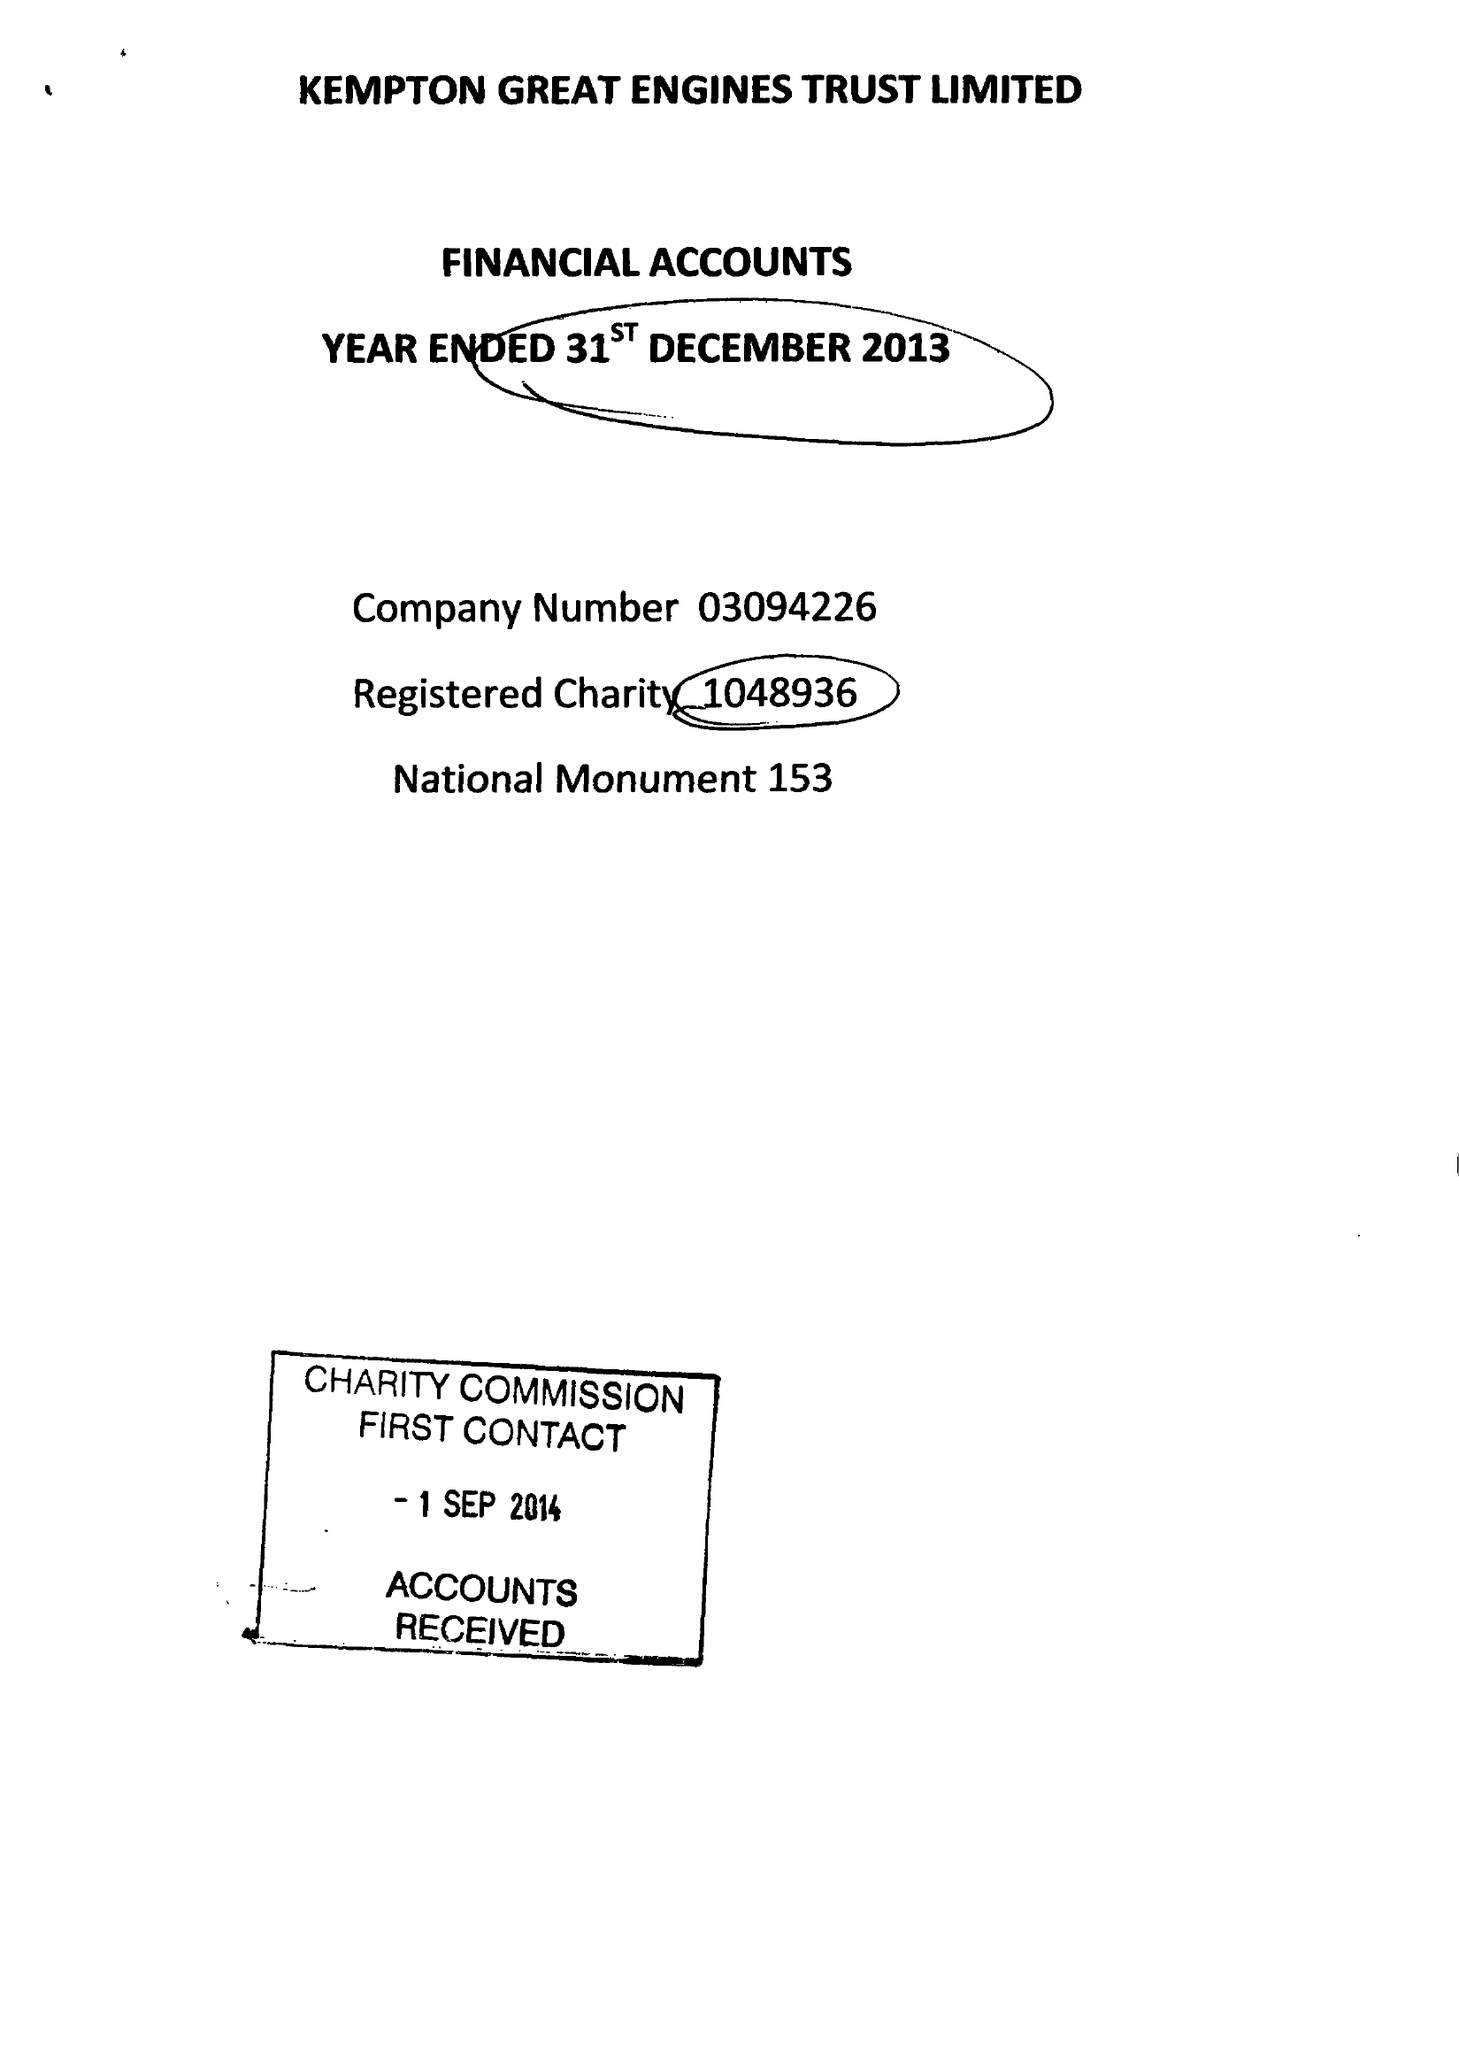What is the value for the address__street_line?
Answer the question using a single word or phrase. SNAKEY LANE 